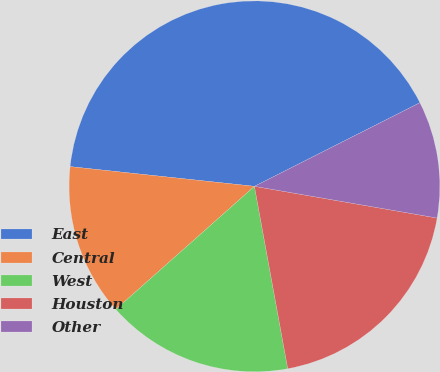Convert chart to OTSL. <chart><loc_0><loc_0><loc_500><loc_500><pie_chart><fcel>East<fcel>Central<fcel>West<fcel>Houston<fcel>Other<nl><fcel>40.86%<fcel>13.25%<fcel>16.32%<fcel>19.39%<fcel>10.18%<nl></chart> 